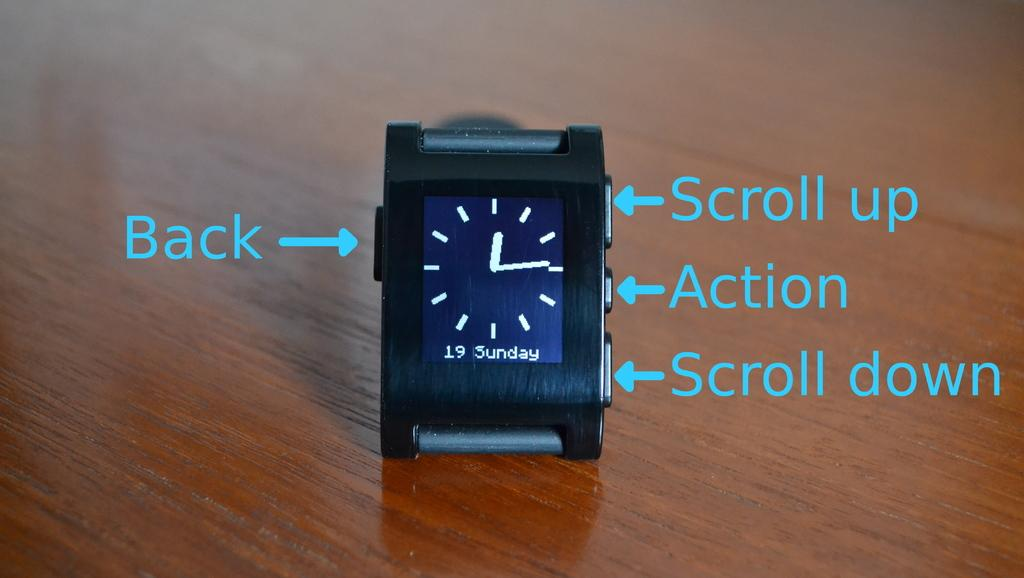<image>
Relay a brief, clear account of the picture shown. A small clock with instructions on how to Scroll up and Scroll down. 